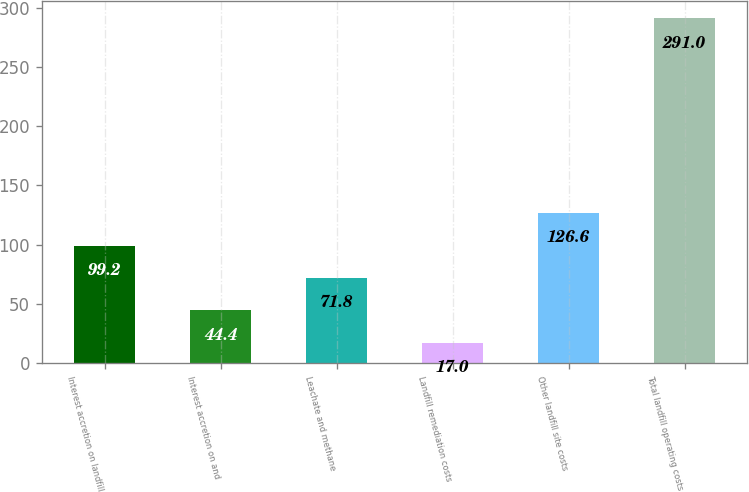Convert chart. <chart><loc_0><loc_0><loc_500><loc_500><bar_chart><fcel>Interest accretion on landfill<fcel>Interest accretion on and<fcel>Leachate and methane<fcel>Landfill remediation costs<fcel>Other landfill site costs<fcel>Total landfill operating costs<nl><fcel>99.2<fcel>44.4<fcel>71.8<fcel>17<fcel>126.6<fcel>291<nl></chart> 